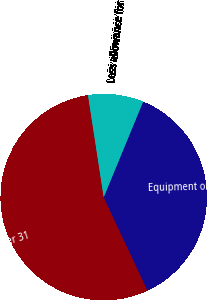Convert chart. <chart><loc_0><loc_0><loc_500><loc_500><pie_chart><fcel>At December 31<fcel>Equipment on operating leases<fcel>Less allowance for<nl><fcel>54.55%<fcel>36.79%<fcel>8.66%<nl></chart> 